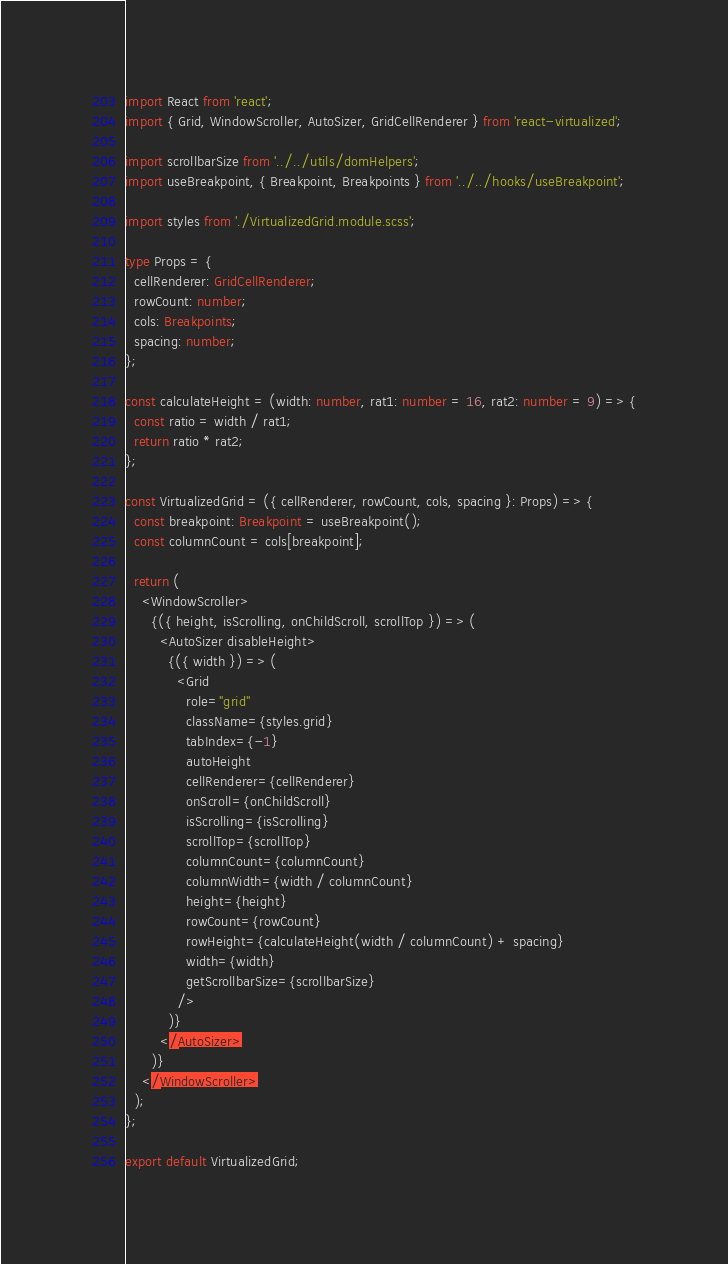Convert code to text. <code><loc_0><loc_0><loc_500><loc_500><_TypeScript_>import React from 'react';
import { Grid, WindowScroller, AutoSizer, GridCellRenderer } from 'react-virtualized';

import scrollbarSize from '../../utils/domHelpers';
import useBreakpoint, { Breakpoint, Breakpoints } from '../../hooks/useBreakpoint';

import styles from './VirtualizedGrid.module.scss';

type Props = {
  cellRenderer: GridCellRenderer;
  rowCount: number;
  cols: Breakpoints;
  spacing: number;
};

const calculateHeight = (width: number, rat1: number = 16, rat2: number = 9) => {
  const ratio = width / rat1;
  return ratio * rat2;
};

const VirtualizedGrid = ({ cellRenderer, rowCount, cols, spacing }: Props) => {
  const breakpoint: Breakpoint = useBreakpoint();
  const columnCount = cols[breakpoint];

  return (
    <WindowScroller>
      {({ height, isScrolling, onChildScroll, scrollTop }) => (
        <AutoSizer disableHeight>
          {({ width }) => (
            <Grid
              role="grid"
              className={styles.grid}
              tabIndex={-1}
              autoHeight
              cellRenderer={cellRenderer}
              onScroll={onChildScroll}
              isScrolling={isScrolling}
              scrollTop={scrollTop}
              columnCount={columnCount}
              columnWidth={width / columnCount}
              height={height}
              rowCount={rowCount}
              rowHeight={calculateHeight(width / columnCount) + spacing}
              width={width}
              getScrollbarSize={scrollbarSize}
            />
          )}
        </AutoSizer>
      )}
    </WindowScroller>
  );
};

export default VirtualizedGrid;
</code> 